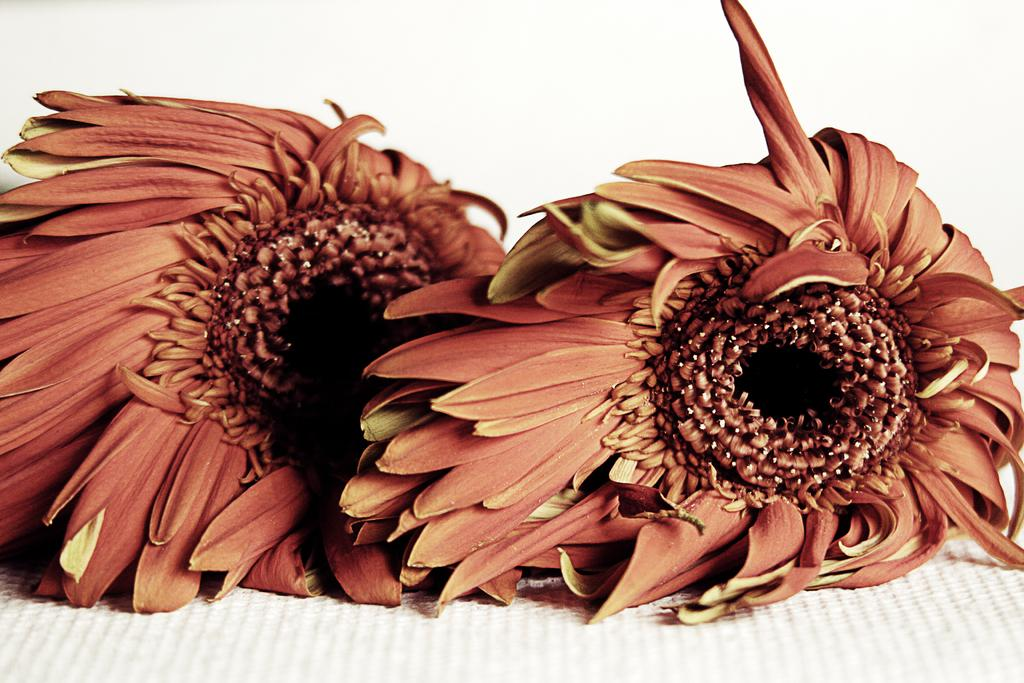What type of flowers are in the image? There are sunflowers in the image. What color is the surface on which the sunflowers are placed? The sunflowers are on a white surface. What type of hair can be seen on the sunflowers in the image? Sunflowers do not have hair, so there is no hair visible on the sunflowers in the image. What type of berry is growing on the sunflowers in the image? Sunflowers do not produce berries, so there are no berries growing on the sunflowers in the image. 